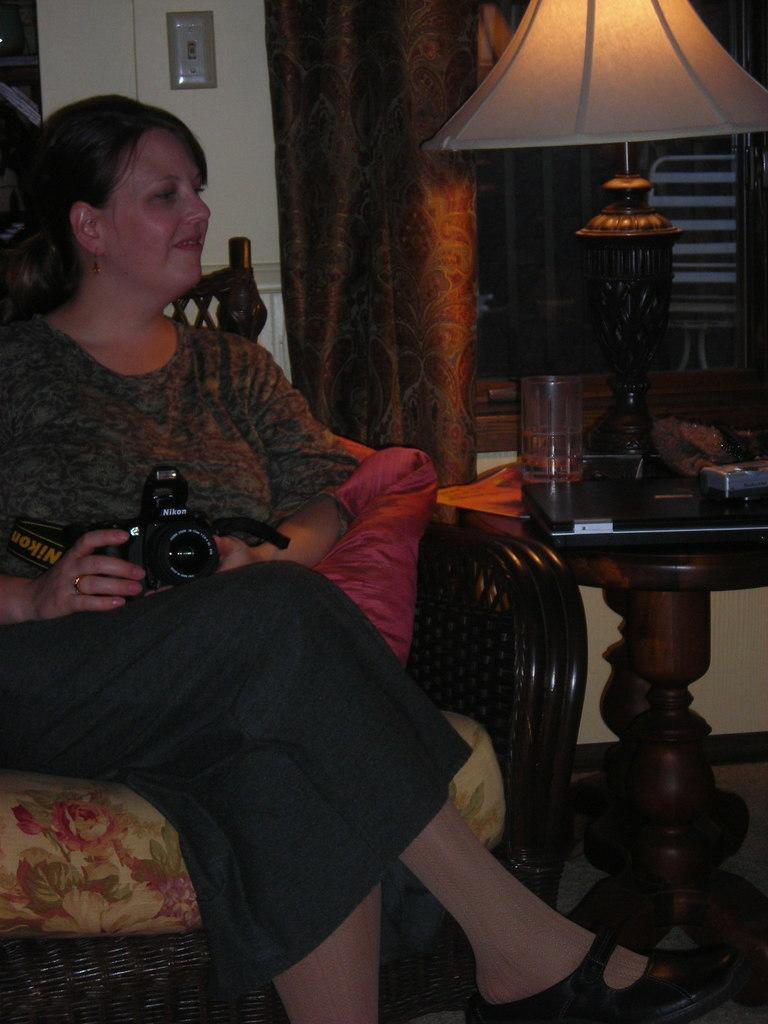Could you give a brief overview of what you see in this image? Lady holding a camera in her hand. She sat on a sofa. To the right corner there is a table. On that table there is a laptop, and a lamp and a glass on it. In the background there is window and a curtain. 